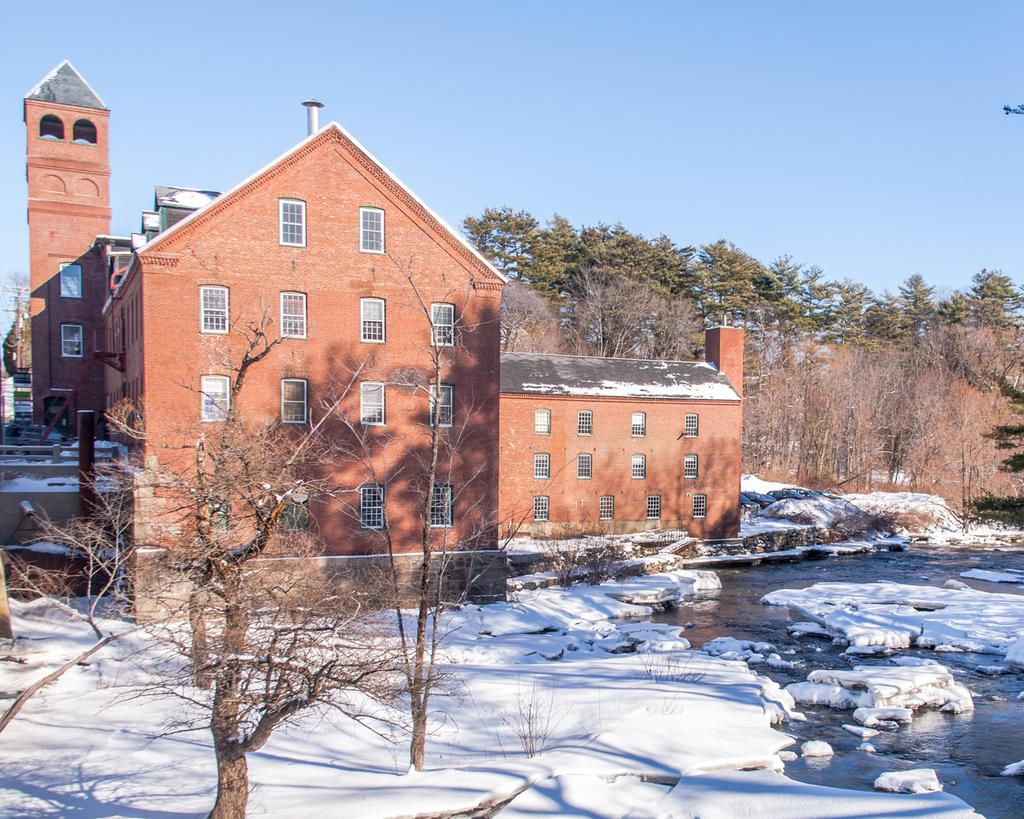What type of structure is visible in the image? There is a house with windows in the image. What natural elements can be seen in the image? There are trees and snow visible at the bottom of the image. Is there any water present in the image? Yes, there is water at the bottom of the image. What part of the natural environment is visible in the image? The sky is visible at the top of the image. What time does the clock on the wall indicate in the image? There is no clock present in the image, so it is not possible to determine the time. 